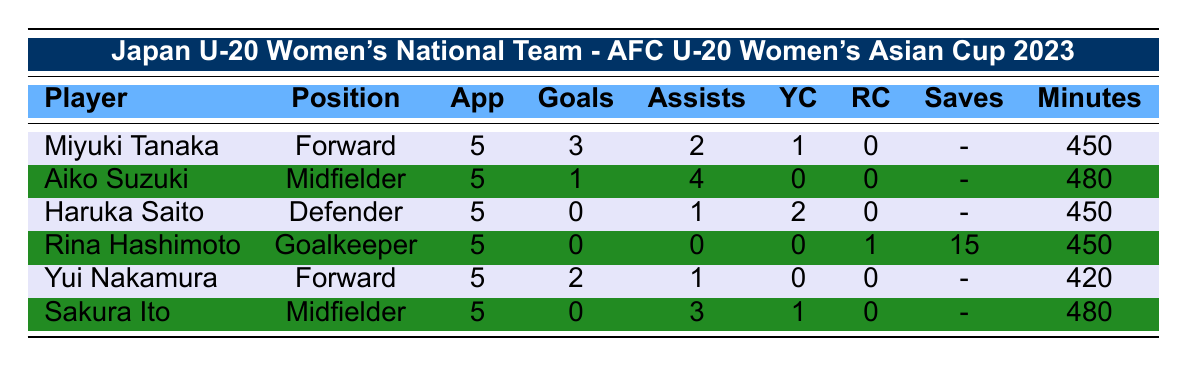What is the total number of goals scored by the Japan U-20 Women's National Team? To find the total number of goals, add the goals scored by each player: 3 (Miyuki Tanaka) + 1 (Aiko Suzuki) + 0 (Haruka Saito) + 0 (Rina Hashimoto) + 2 (Yui Nakamura) + 0 (Sakura Ito) = 6.
Answer: 6 Who has the highest number of assists in the team? The number of assists for each player is: 2 (Miyuki Tanaka), 4 (Aiko Suzuki), 1 (Haruka Saito), 0 (Rina Hashimoto), 1 (Yui Nakamura), and 3 (Sakura Ito). The highest is 4, scored by Aiko Suzuki.
Answer: Aiko Suzuki Did any player receive a red card? Rina Hashimoto received a red card as indicated in the table.
Answer: Yes What is the average number of minutes played by the players? Calculate the total minutes played: 450 + 480 + 450 + 450 + 420 + 480 = 2280. There are 6 players, so divide 2280 by 6: 2280 / 6 = 380.
Answer: 380 How many players have more than 1 assist? The players with assists more than 1 are Aiko Suzuki (4) and Sakura Ito (3), totaling 2 players.
Answer: 2 What percentage of the team's appearances resulted in goals? The total appearances are 5 players each playing 5 matches, totaling 25 appearances. The team scored 6 goals. To calculate the percentage: (6 / 25) * 100 = 24%.
Answer: 24% How many yellow cards did the team receive in total? Add up all the yellow cards: 1 (Miyuki Tanaka) + 0 (Aiko Suzuki) + 2 (Haruka Saito) + 0 (Rina Hashimoto) + 0 (Yui Nakamura) + 1 (Sakura Ito) = 4.
Answer: 4 Which position has the most goals scored? For forwards, goals are 3 (Miyuki Tanaka) + 2 (Yui Nakamura) = 5; for midfielders, it’s 1 (Aiko Suzuki) + 0 (Sakura Ito) = 1; for defenders and goalkeepers, it’s 0. The forwards scored the most with 5 goals.
Answer: Forward How many players made at least one assist? Players with assists: Miyuki Tanaka (2), Aiko Suzuki (4), Haruka Saito (1), Yui Nakamura (1), and Sakura Ito (3). That’s a total of 5 players with assists.
Answer: 5 Is there a player who played every minute of the tournament? The appearances show Aiko Suzuki played 480 minutes (the max possible in 5 games), meaning she played every minute of the tournament.
Answer: Yes 